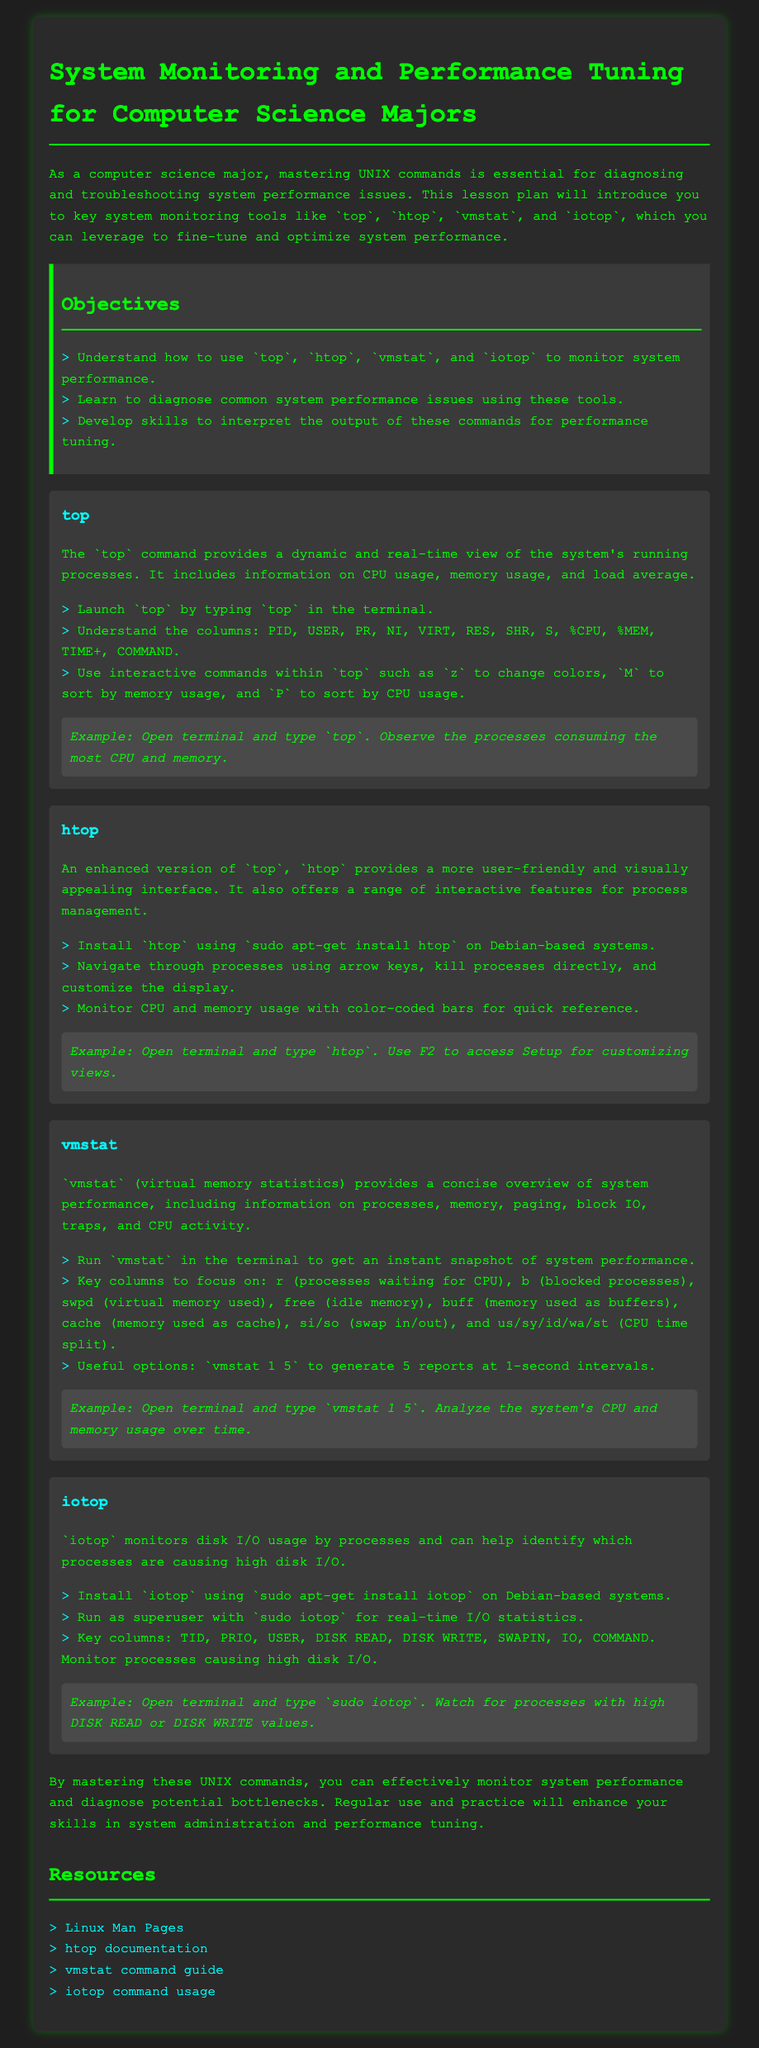what is the title of the lesson plan? The title is explicitly stated at the top of the document.
Answer: System Monitoring and Performance Tuning for Computer Science Majors how many key system monitoring tools are introduced? The number of tools is specified in the objectives section of the document.
Answer: Four what command provides a dynamic view of system processes? The command that provides this information is detailed in the section dedicated to it.
Answer: top which command offers a user-friendly interface for process management? The document describes one command specifically noted for its enhanced interface.
Answer: htop what key column in vmstat represents processes waiting for CPU? The relevant performance indicator is defined in the description of the vmstat command.
Answer: r what should you install to use iotop on Debian-based systems? The installation method is described in the iotop section of the lesson plan.
Answer: sudo apt-get install iotop which interactive command in top allows you to sort by memory usage? The document lists interactive commands used within the top command.
Answer: M how can you customize views in htop? The method for customization is mentioned in the htop command section.
Answer: F2 what is the main purpose of the resources section? The resources section provides additional information related to the commands discussed.
Answer: Additional information what is the output format of the command vmstat 1 5? The output format is indicated as part of the vmstat command explanation.
Answer: Five reports at one-second intervals 